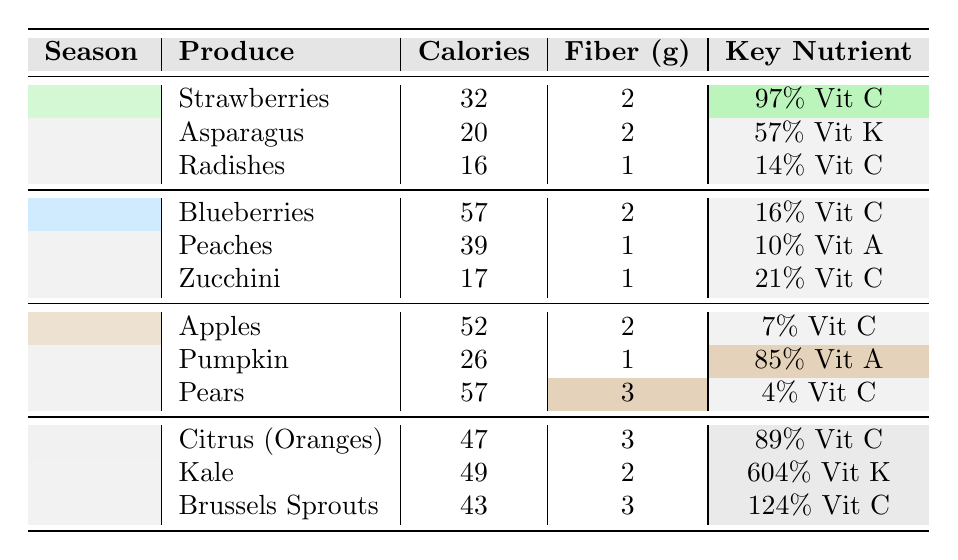What fruit has the highest vitamin C content in Spring? Strawberries have 97% of the daily value for vitamin C, which is the highest amongst the listed fruits for Spring.
Answer: Strawberries Which season has the highest fiber content in a single fruit? Kale has the highest fiber content with 2 grams, and it is found in Winter.
Answer: 2 grams in Winter (Kale) How many calories do Zucchini have? Zucchini is listed with 17 calories in the Summer section of the table.
Answer: 17 calories Is Asparagus a good source of vitamin C? Asparagus provides 57% of the daily value for vitamin K but only has 14% for vitamin C, therefore it is not considered a good source of vitamin C.
Answer: No What is the average calorie content of the fruits in Fall? The fruits in Fall (Apples, Pumpkin, and Pears) have calories totaling 52 + 26 + 57 = 135. Dividing by the 3 fruits gives an average of 45.
Answer: 45 calories Which fruit has more calories, Blueberries or Peaches? Blueberries have 57 calories while Peaches have 39 calories; thus, Blueberries have more calories.
Answer: Blueberries What is the key nutrient of Kale? Kale contains an impressive 604% of the daily value for vitamin K, which is its key nutrient.
Answer: 604% vitamin K How does the fiber content of Apples compare to that of Brussels Sprouts? Apples have 2 grams of fiber while Brussels Sprouts have 3 grams; therefore, Brussels Sprouts have more fiber than Apples.
Answer: Brussels Sprouts have more fiber Which season features the fruit with the highest vitamin A content? The fruit with the highest vitamin A content is Pumpkin at 85%, which is found in Fall.
Answer: Fall (Pumpkin) What is the total fiber content of all the fruits in Summer? The total fiber content in Summer can be calculated by adding the fiber from Blueberries (2), Peaches (1), and Zucchini (1), which gives a total of 4 grams.
Answer: 4 grams 